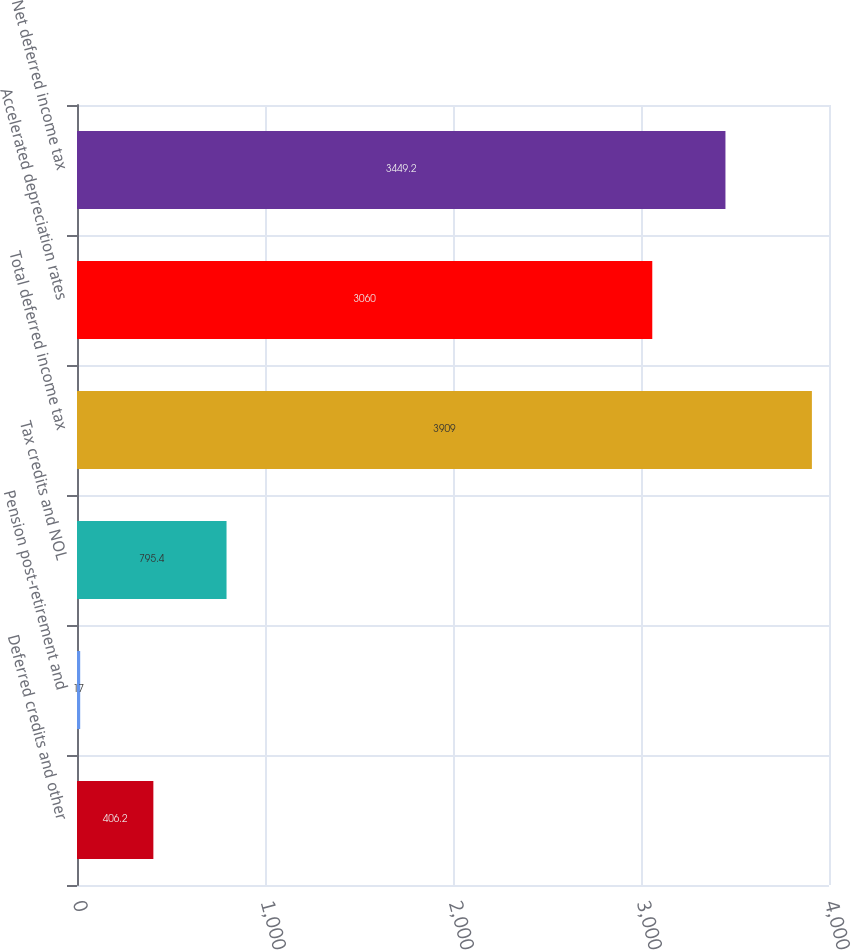Convert chart to OTSL. <chart><loc_0><loc_0><loc_500><loc_500><bar_chart><fcel>Deferred credits and other<fcel>Pension post-retirement and<fcel>Tax credits and NOL<fcel>Total deferred income tax<fcel>Accelerated depreciation rates<fcel>Net deferred income tax<nl><fcel>406.2<fcel>17<fcel>795.4<fcel>3909<fcel>3060<fcel>3449.2<nl></chart> 